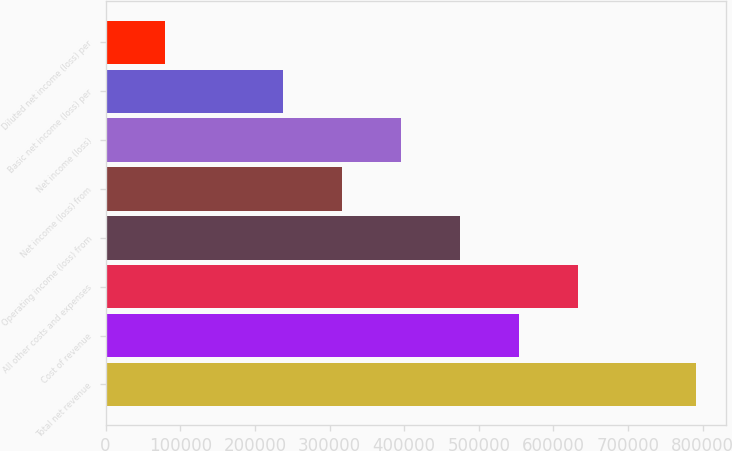Convert chart. <chart><loc_0><loc_0><loc_500><loc_500><bar_chart><fcel>Total net revenue<fcel>Cost of revenue<fcel>All other costs and expenses<fcel>Operating income (loss) from<fcel>Net income (loss) from<fcel>Net income (loss)<fcel>Basic net income (loss) per<fcel>Diluted net income (loss) per<nl><fcel>790976<fcel>553683<fcel>632781<fcel>474586<fcel>316391<fcel>395488<fcel>237293<fcel>79097.8<nl></chart> 